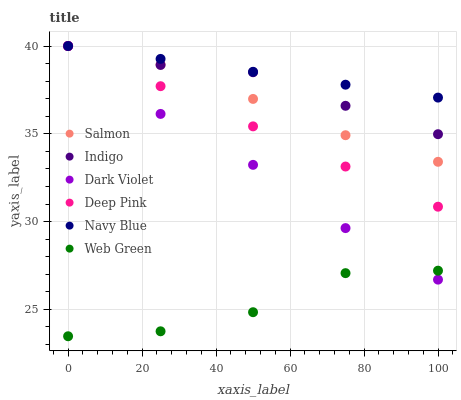Does Web Green have the minimum area under the curve?
Answer yes or no. Yes. Does Navy Blue have the maximum area under the curve?
Answer yes or no. Yes. Does Indigo have the minimum area under the curve?
Answer yes or no. No. Does Indigo have the maximum area under the curve?
Answer yes or no. No. Is Navy Blue the smoothest?
Answer yes or no. Yes. Is Web Green the roughest?
Answer yes or no. Yes. Is Indigo the smoothest?
Answer yes or no. No. Is Indigo the roughest?
Answer yes or no. No. Does Web Green have the lowest value?
Answer yes or no. Yes. Does Indigo have the lowest value?
Answer yes or no. No. Does Dark Violet have the highest value?
Answer yes or no. Yes. Does Web Green have the highest value?
Answer yes or no. No. Is Web Green less than Salmon?
Answer yes or no. Yes. Is Indigo greater than Web Green?
Answer yes or no. Yes. Does Dark Violet intersect Indigo?
Answer yes or no. Yes. Is Dark Violet less than Indigo?
Answer yes or no. No. Is Dark Violet greater than Indigo?
Answer yes or no. No. Does Web Green intersect Salmon?
Answer yes or no. No. 